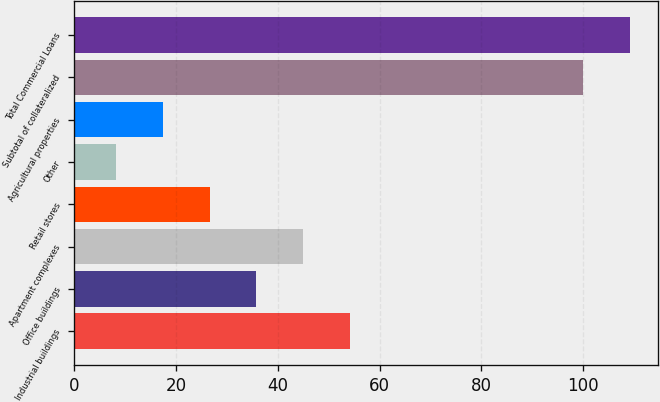Convert chart to OTSL. <chart><loc_0><loc_0><loc_500><loc_500><bar_chart><fcel>Industrial buildings<fcel>Office buildings<fcel>Apartment complexes<fcel>Retail stores<fcel>Other<fcel>Agricultural properties<fcel>Subtotal of collateralized<fcel>Total Commercial Loans<nl><fcel>54.1<fcel>35.74<fcel>44.92<fcel>26.56<fcel>8.2<fcel>17.38<fcel>100<fcel>109.18<nl></chart> 